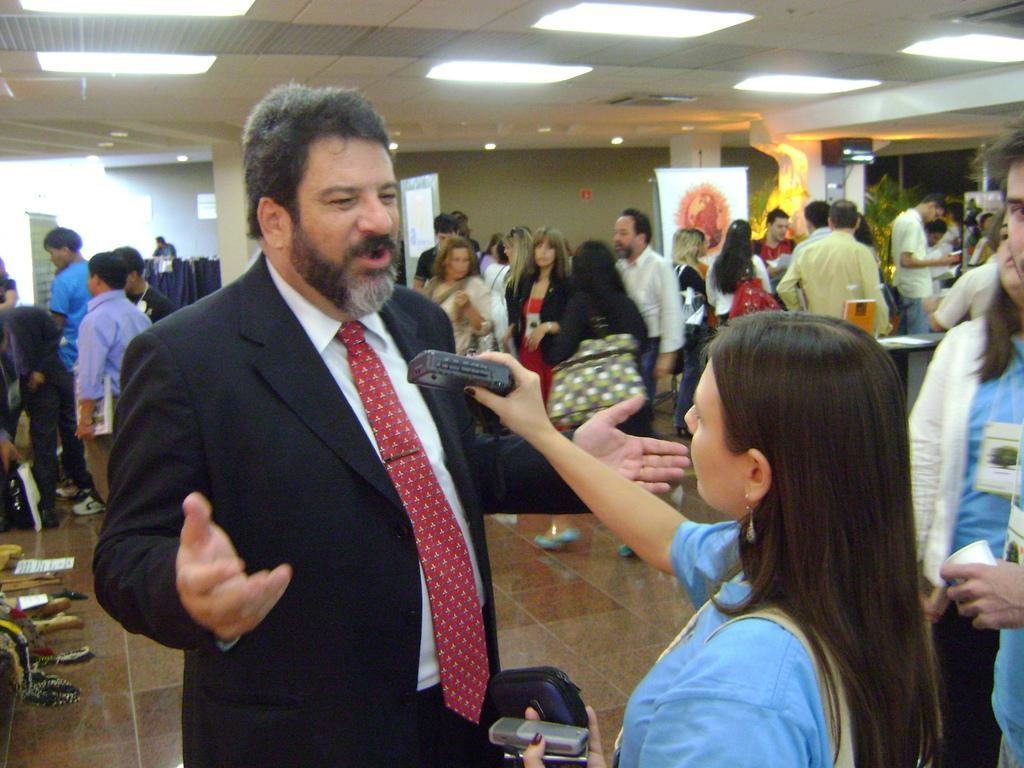Could you give a brief overview of what you see in this image? On the left side, there is a person in a suit standing and speaking. On the right side, there is a woman holding a device and standing. Behind her, there are two persons. In the background, there are other person's, a plant, pillars, a wall, a screen and other objects. 